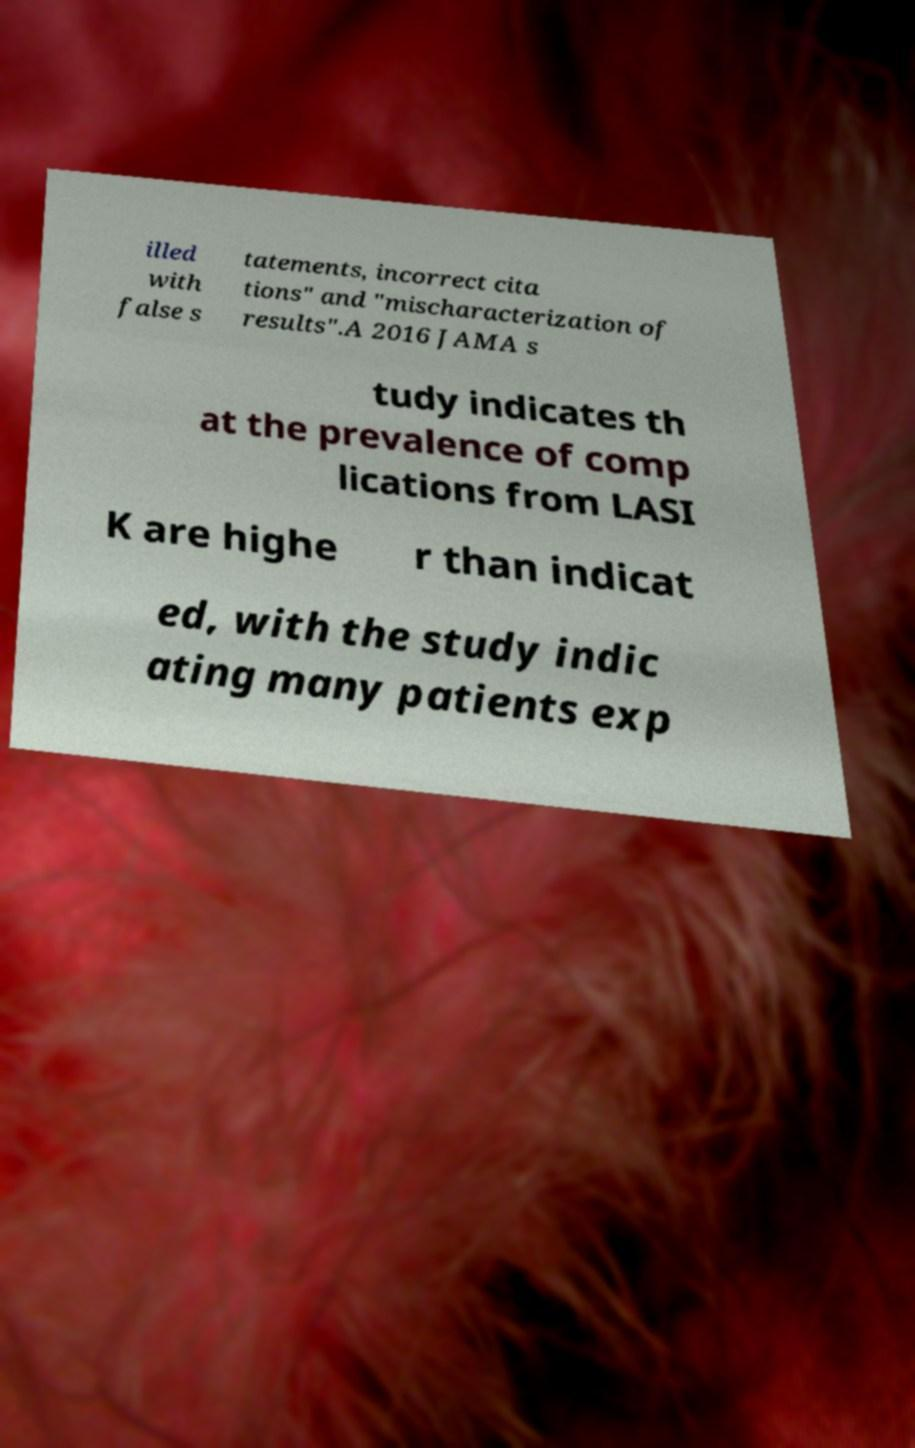Can you accurately transcribe the text from the provided image for me? illed with false s tatements, incorrect cita tions" and "mischaracterization of results".A 2016 JAMA s tudy indicates th at the prevalence of comp lications from LASI K are highe r than indicat ed, with the study indic ating many patients exp 